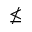<formula> <loc_0><loc_0><loc_500><loc_500>\nleq</formula> 